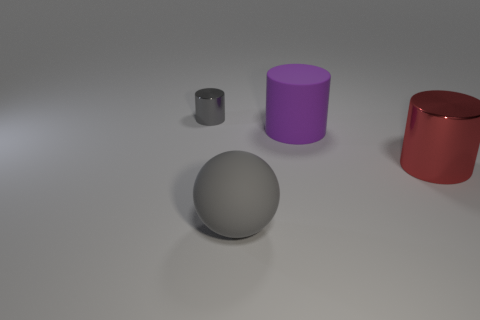Are there any other things that are the same shape as the large gray object?
Provide a short and direct response. No. Are there any small metallic cylinders in front of the big gray rubber thing?
Offer a very short reply. No. Are the large red object and the tiny gray object made of the same material?
Give a very brief answer. Yes. There is another shiny object that is the same shape as the small shiny object; what color is it?
Offer a terse response. Red. Do the big thing in front of the red cylinder and the tiny shiny thing have the same color?
Provide a short and direct response. Yes. What shape is the big matte object that is the same color as the tiny metallic object?
Give a very brief answer. Sphere. How many cylinders are the same material as the big red object?
Make the answer very short. 1. How many cylinders are right of the large matte cylinder?
Your answer should be compact. 1. What size is the rubber cylinder?
Provide a succinct answer. Large. The matte cylinder that is the same size as the red thing is what color?
Provide a succinct answer. Purple. 